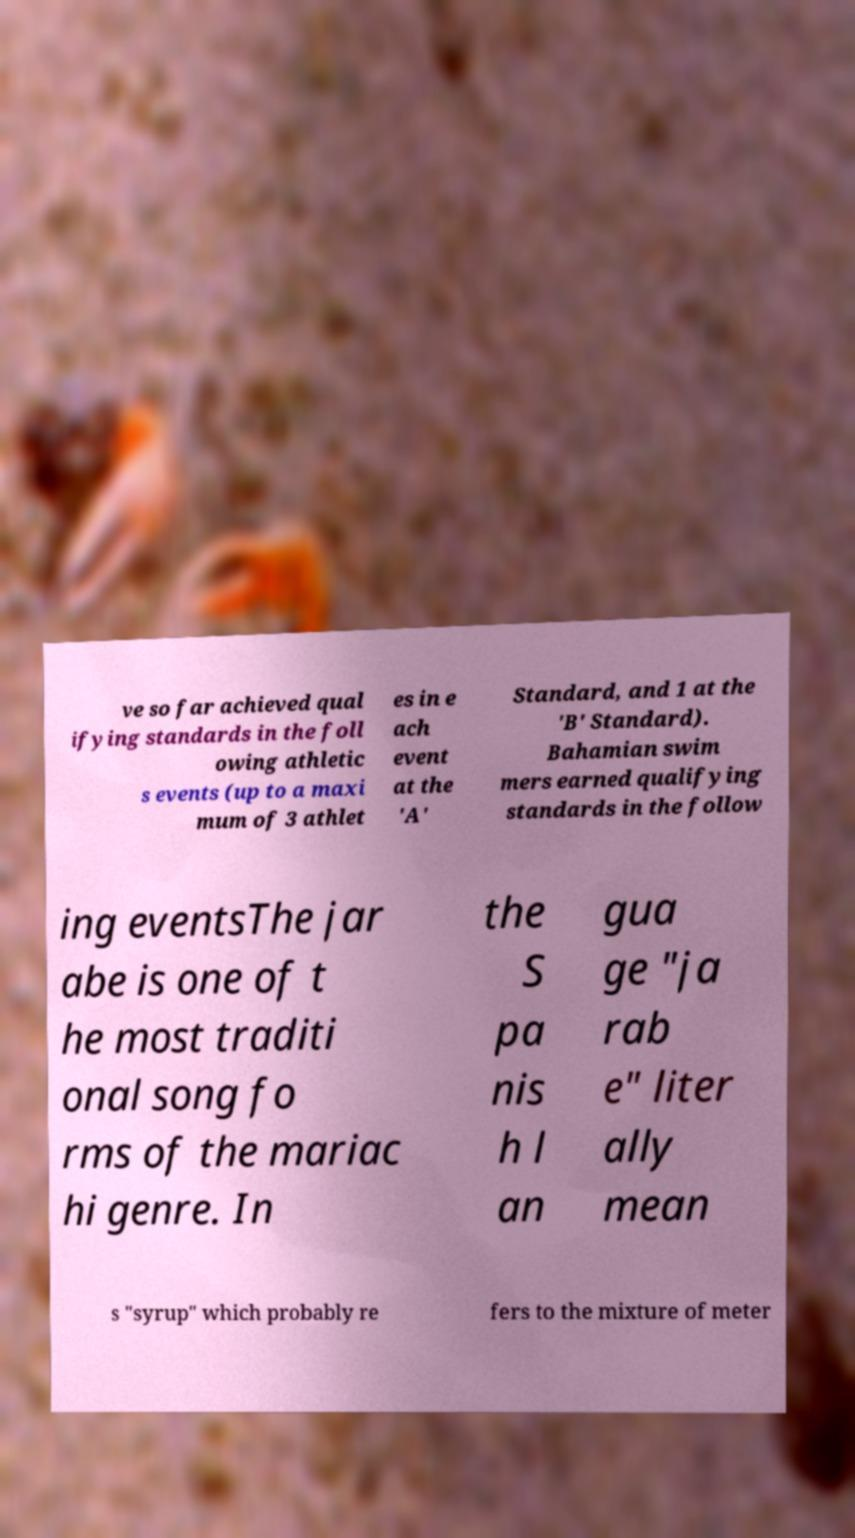Can you accurately transcribe the text from the provided image for me? ve so far achieved qual ifying standards in the foll owing athletic s events (up to a maxi mum of 3 athlet es in e ach event at the 'A' Standard, and 1 at the 'B' Standard). Bahamian swim mers earned qualifying standards in the follow ing eventsThe jar abe is one of t he most traditi onal song fo rms of the mariac hi genre. In the S pa nis h l an gua ge "ja rab e" liter ally mean s "syrup" which probably re fers to the mixture of meter 